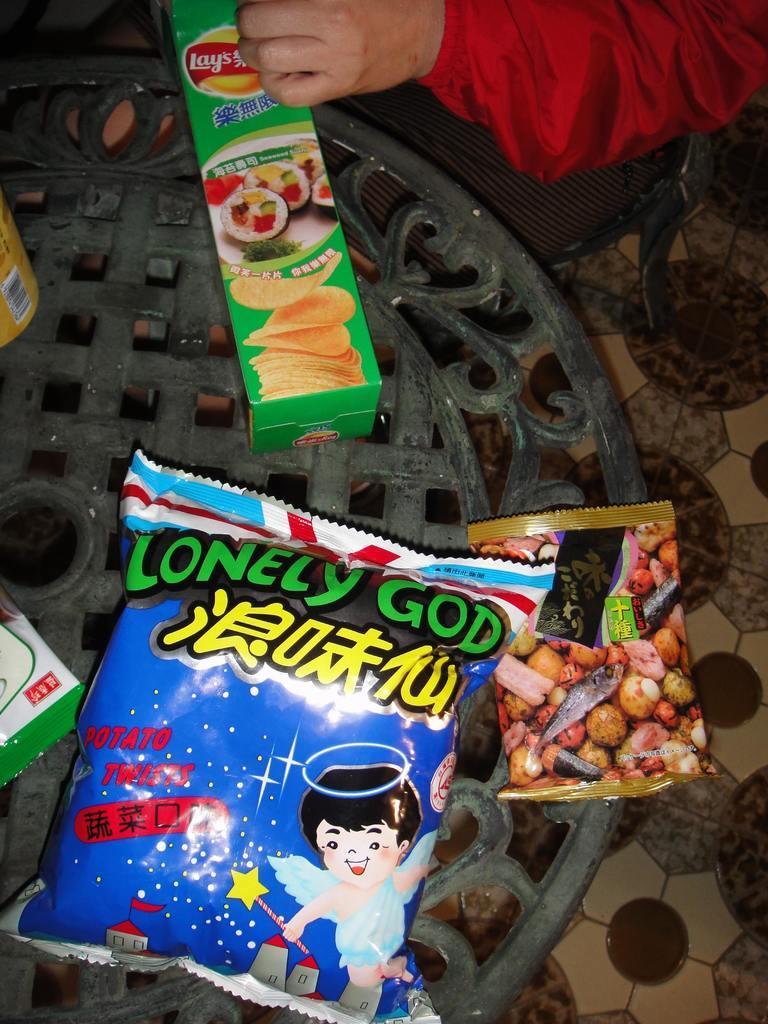Could you give a brief overview of what you see in this image? In this picture we can see packets on a table and bedside to this table we can see a person sitting on a chair. 